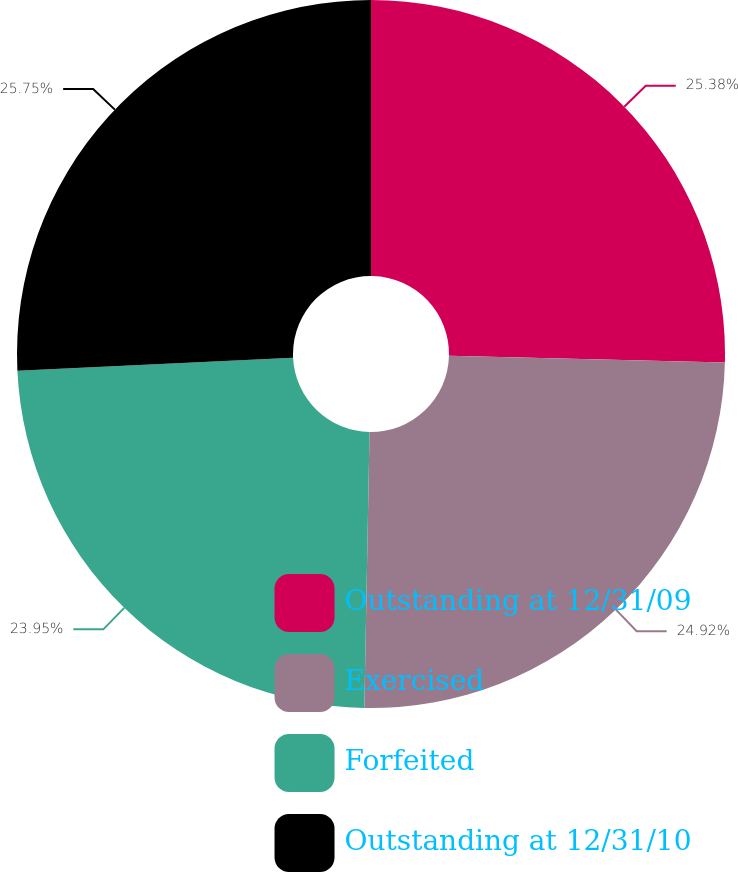<chart> <loc_0><loc_0><loc_500><loc_500><pie_chart><fcel>Outstanding at 12/31/09<fcel>Exercised<fcel>Forfeited<fcel>Outstanding at 12/31/10<nl><fcel>25.38%<fcel>24.92%<fcel>23.95%<fcel>25.75%<nl></chart> 